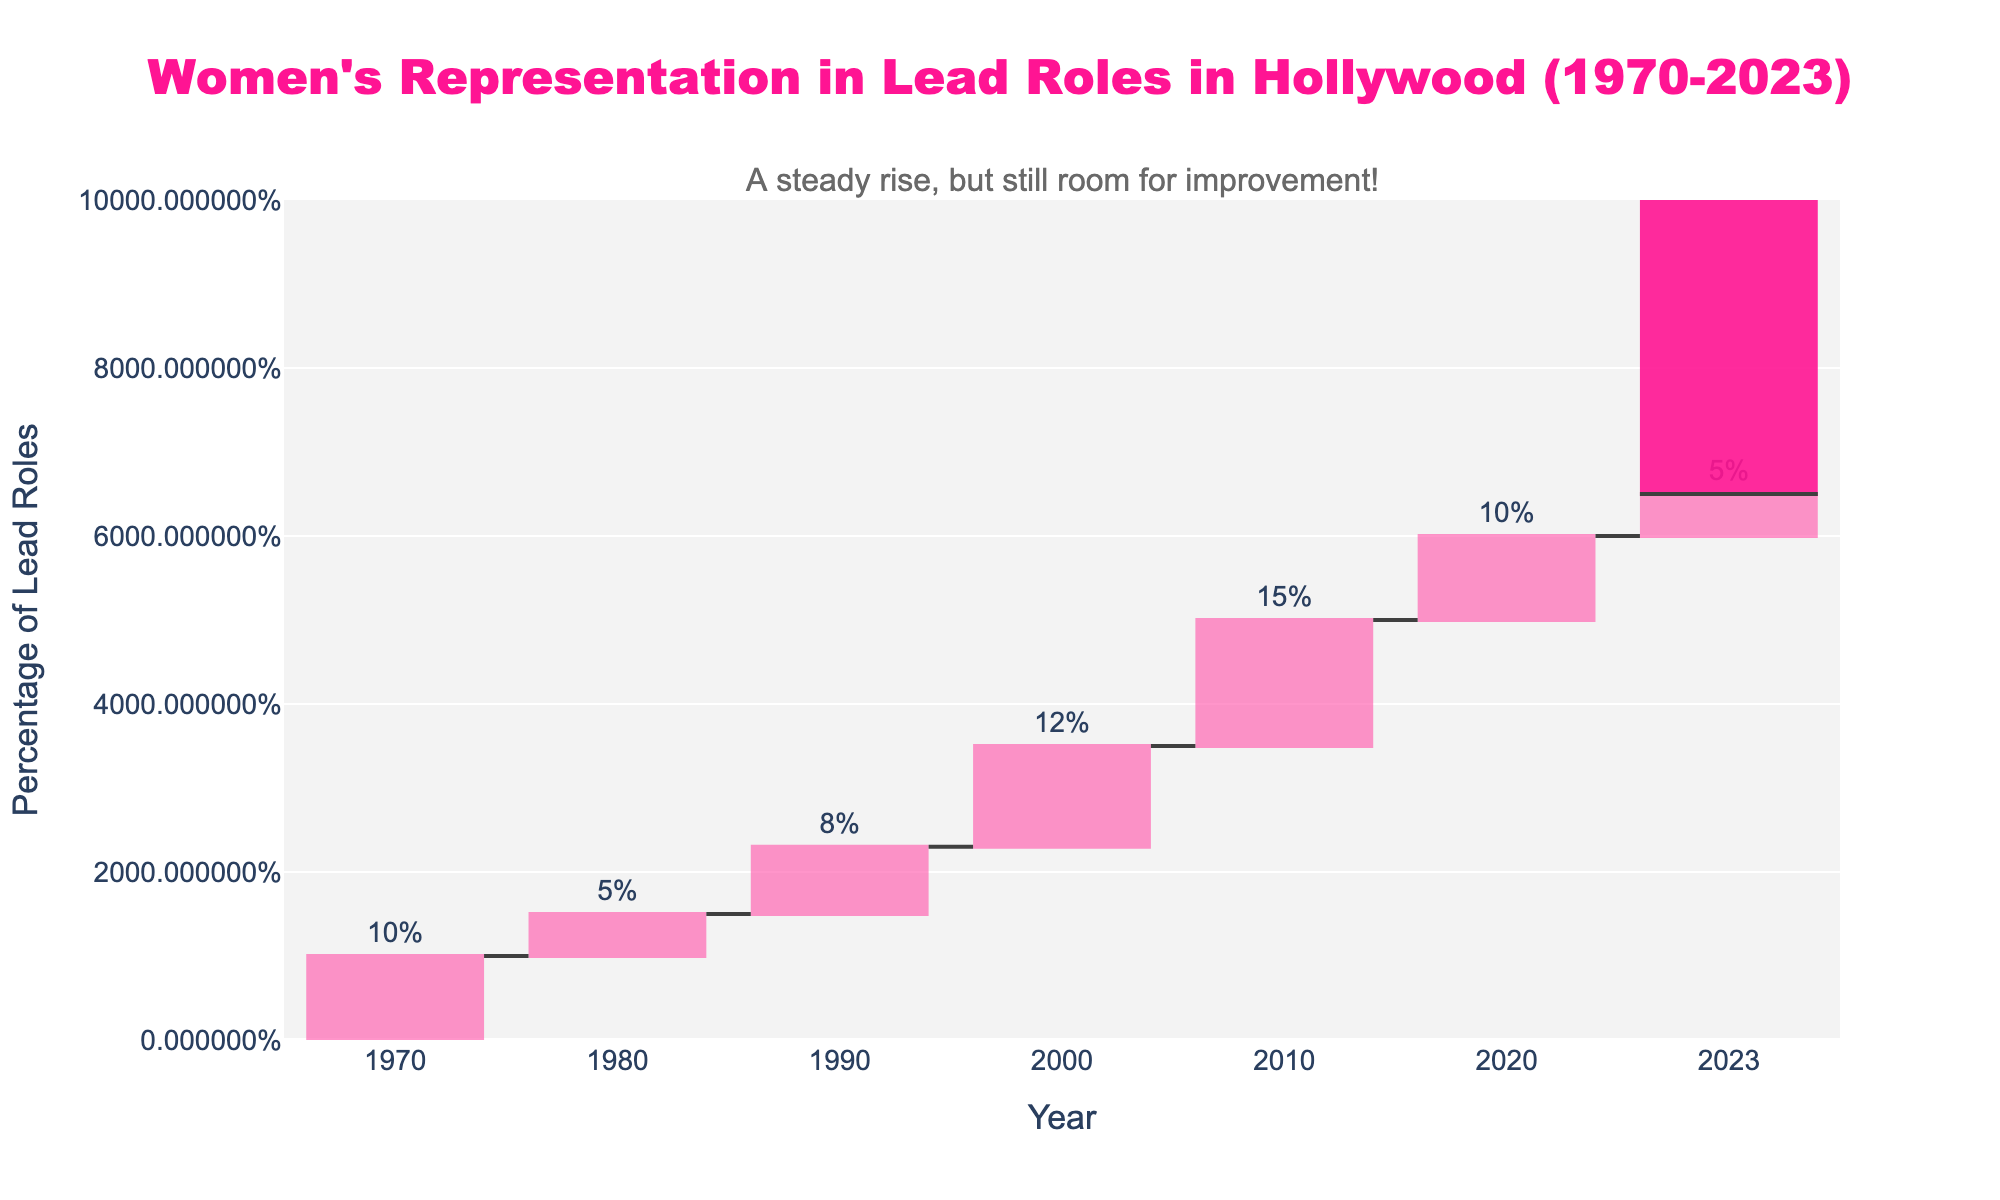what is the title of the chart? The title of the chart is centrally placed at the top and reads "Women's Representation in Lead Roles in Hollywood (1970-2023)"
Answer: Women's Representation in Lead Roles in Hollywood (1970-2023) what does the y-axis represent? The y-axis represents the percentage of lead roles held by women, ranging from 0% to 100%
Answer: Percentage of Lead Roles how many data points are displayed in the chart? There are 7 years listed plus a total, making 8 data points in total
Answer: 8 In which year was the highest increase in women's representation in lead roles? The highest increase happened in the year 2010 with a 15% change
Answer: 2010 What is the cumulative percentage of lead roles held by women as of 2023? The cumulative percentage for 2023 can be found represented by the final total bar in the chart, which displays 65%
Answer: 65% How did the representation change from 1980 to 1990? To determine the change, subtract the figures between the two years: 23% (1990) - 15% (1980) = 8% increase
Answer: Increased by 8% What is the average representation increase per decade from 1970 to 2020? Sum the increases (10% + 5% + 8% + 12% + 15% + 10% = 60%) and divide by the number of decades (6): 60/6 = 10% per decade
Answer: 10% per decade Which decade shows the smallest increase in women's representation in lead roles? By comparing the incremental changes, the smallest increase is from the 1980s with a 5% change
Answer: 1980s What has been the trend in women's representation in lead roles from 1970 to 2020? The trend shows a steady increase in women’s representation as evidenced by increasing values in a stepwise manner over the years
Answer: Steady increase What's the difference in the representation increase from 1970 to 1980 and 2010 to 2020? Compute the differences: From 1970 to 1980: 10% - 5% = 5%; From 2010 to 2020: 10% - 15% = -5%. (Compare 5% increase to -5% decrease)
Answer: 10% 